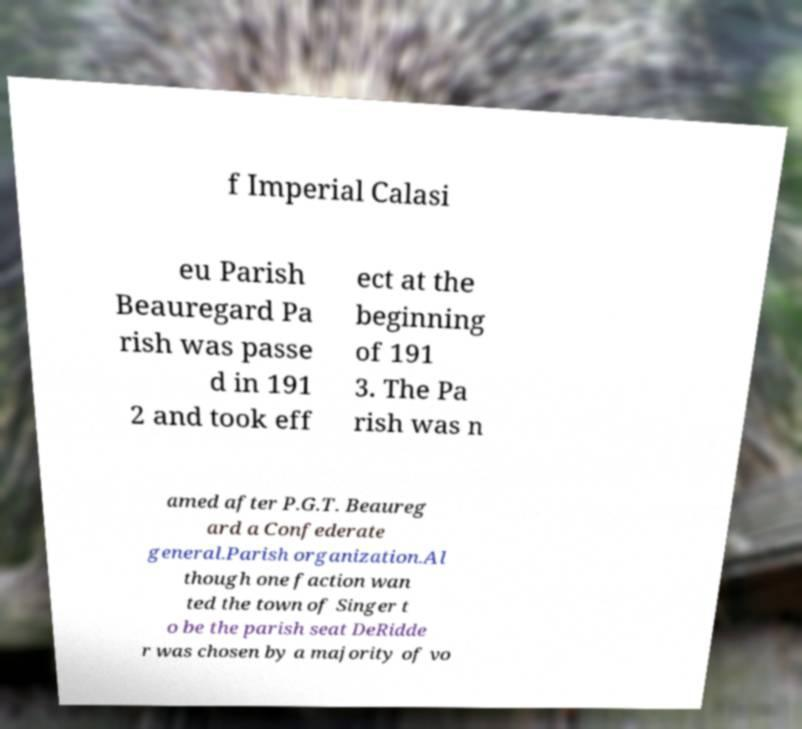Can you read and provide the text displayed in the image?This photo seems to have some interesting text. Can you extract and type it out for me? f Imperial Calasi eu Parish Beauregard Pa rish was passe d in 191 2 and took eff ect at the beginning of 191 3. The Pa rish was n amed after P.G.T. Beaureg ard a Confederate general.Parish organization.Al though one faction wan ted the town of Singer t o be the parish seat DeRidde r was chosen by a majority of vo 